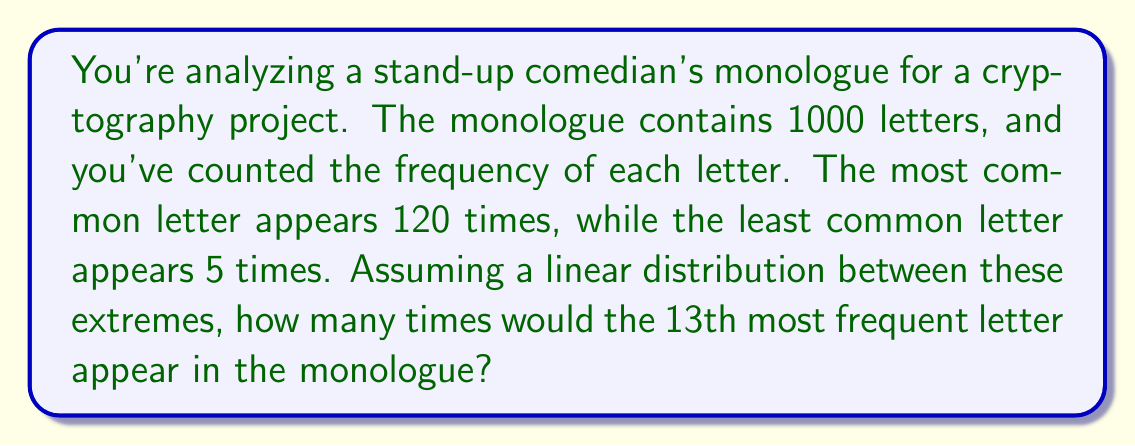Can you answer this question? Let's approach this step-by-step:

1) We have 26 letters in the alphabet. The most frequent letter appears 120 times, and the least frequent appears 5 times.

2) We need to find the linear equation that describes the frequency distribution. Let $x$ be the rank of the letter (1 being most frequent, 26 being least frequent) and $y$ be the number of appearances.

3) We can use the point-slope form of a linear equation:
   $y - y_1 = m(x - x_1)$

4) We know two points: (1, 120) and (26, 5)

5) Calculate the slope:
   $m = \frac{y_2 - y_1}{x_2 - x_1} = \frac{5 - 120}{26 - 1} = -\frac{115}{25} = -4.6$

6) Now we can form our equation using (1, 120) as our reference point:
   $y - 120 = -4.6(x - 1)$

7) Simplify:
   $y = -4.6x + 124.6$

8) We want to find y when x = 13 (the 13th most frequent letter):
   $y = -4.6(13) + 124.6 = -59.8 + 124.6 = 64.8$

9) Since we're dealing with whole letters, we round to the nearest integer: 65

Therefore, the 13th most frequent letter would appear approximately 65 times in the monologue.
Answer: 65 